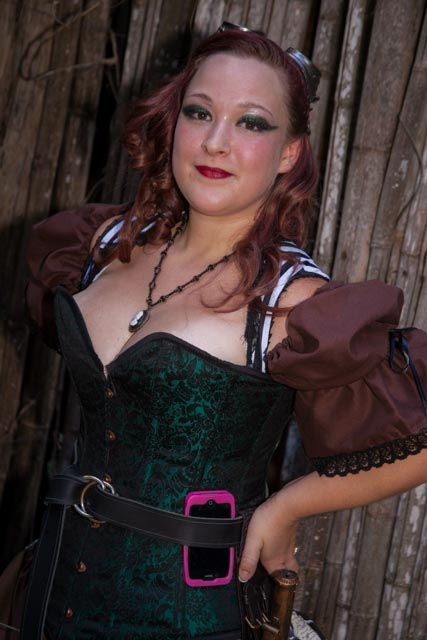Describe the objects in this image and their specific colors. I can see people in black, brown, and maroon tones and cell phone in black and purple tones in this image. 